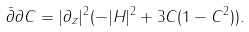Convert formula to latex. <formula><loc_0><loc_0><loc_500><loc_500>\bar { \partial } \partial C = | \partial _ { z } | ^ { 2 } ( - | H | ^ { 2 } + 3 C ( 1 - C ^ { 2 } ) ) .</formula> 